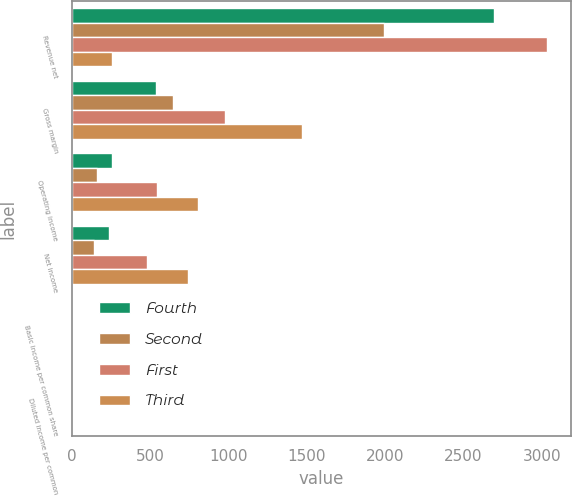<chart> <loc_0><loc_0><loc_500><loc_500><stacked_bar_chart><ecel><fcel>Revenue net<fcel>Gross margin<fcel>Operating income<fcel>Net income<fcel>Basic income per common share<fcel>Diluted income per common<nl><fcel>Fourth<fcel>2694<fcel>541<fcel>259<fcel>239<fcel>1.03<fcel>1.01<nl><fcel>Second<fcel>1995<fcel>648<fcel>162<fcel>145<fcel>0.62<fcel>0.61<nl><fcel>First<fcel>3035<fcel>977<fcel>542<fcel>483<fcel>2<fcel>1.96<nl><fcel>Third<fcel>259<fcel>1472<fcel>808<fcel>745<fcel>2.93<fcel>2.87<nl></chart> 